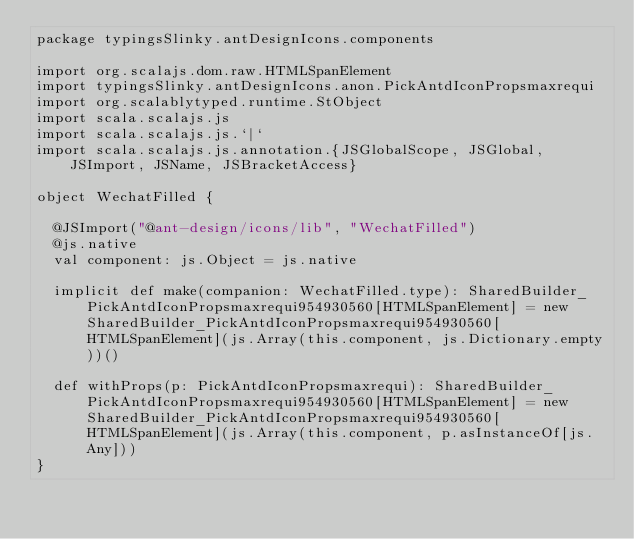<code> <loc_0><loc_0><loc_500><loc_500><_Scala_>package typingsSlinky.antDesignIcons.components

import org.scalajs.dom.raw.HTMLSpanElement
import typingsSlinky.antDesignIcons.anon.PickAntdIconPropsmaxrequi
import org.scalablytyped.runtime.StObject
import scala.scalajs.js
import scala.scalajs.js.`|`
import scala.scalajs.js.annotation.{JSGlobalScope, JSGlobal, JSImport, JSName, JSBracketAccess}

object WechatFilled {
  
  @JSImport("@ant-design/icons/lib", "WechatFilled")
  @js.native
  val component: js.Object = js.native
  
  implicit def make(companion: WechatFilled.type): SharedBuilder_PickAntdIconPropsmaxrequi954930560[HTMLSpanElement] = new SharedBuilder_PickAntdIconPropsmaxrequi954930560[HTMLSpanElement](js.Array(this.component, js.Dictionary.empty))()
  
  def withProps(p: PickAntdIconPropsmaxrequi): SharedBuilder_PickAntdIconPropsmaxrequi954930560[HTMLSpanElement] = new SharedBuilder_PickAntdIconPropsmaxrequi954930560[HTMLSpanElement](js.Array(this.component, p.asInstanceOf[js.Any]))
}
</code> 